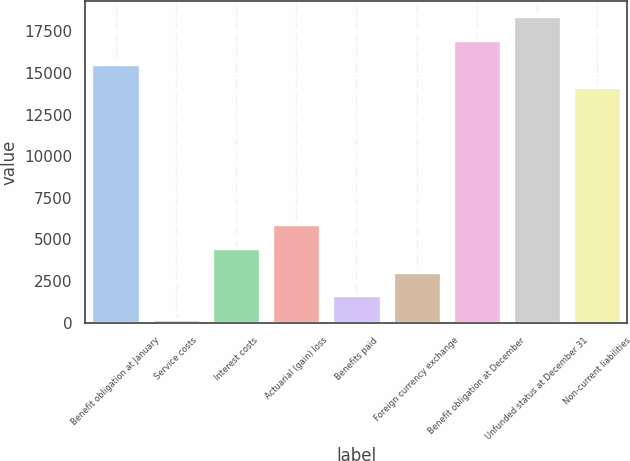Convert chart to OTSL. <chart><loc_0><loc_0><loc_500><loc_500><bar_chart><fcel>Benefit obligation at January<fcel>Service costs<fcel>Interest costs<fcel>Actuarial (gain) loss<fcel>Benefits paid<fcel>Foreign currency exchange<fcel>Benefit obligation at December<fcel>Unfunded status at December 31<fcel>Non-current liabilities<nl><fcel>15554.2<fcel>215<fcel>4481.6<fcel>5903.8<fcel>1637.2<fcel>3059.4<fcel>16976.4<fcel>18398.6<fcel>14132<nl></chart> 